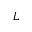Convert formula to latex. <formula><loc_0><loc_0><loc_500><loc_500>L</formula> 